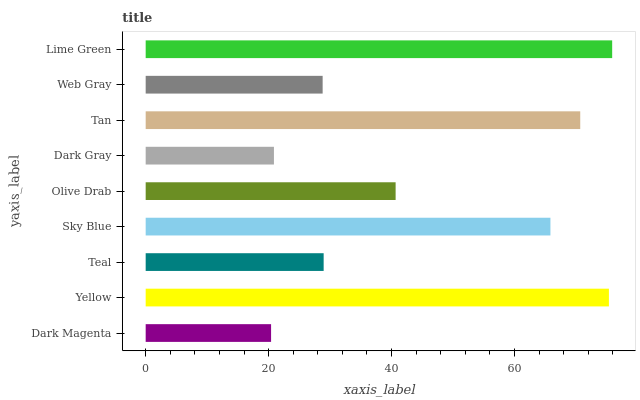Is Dark Magenta the minimum?
Answer yes or no. Yes. Is Lime Green the maximum?
Answer yes or no. Yes. Is Yellow the minimum?
Answer yes or no. No. Is Yellow the maximum?
Answer yes or no. No. Is Yellow greater than Dark Magenta?
Answer yes or no. Yes. Is Dark Magenta less than Yellow?
Answer yes or no. Yes. Is Dark Magenta greater than Yellow?
Answer yes or no. No. Is Yellow less than Dark Magenta?
Answer yes or no. No. Is Olive Drab the high median?
Answer yes or no. Yes. Is Olive Drab the low median?
Answer yes or no. Yes. Is Lime Green the high median?
Answer yes or no. No. Is Yellow the low median?
Answer yes or no. No. 